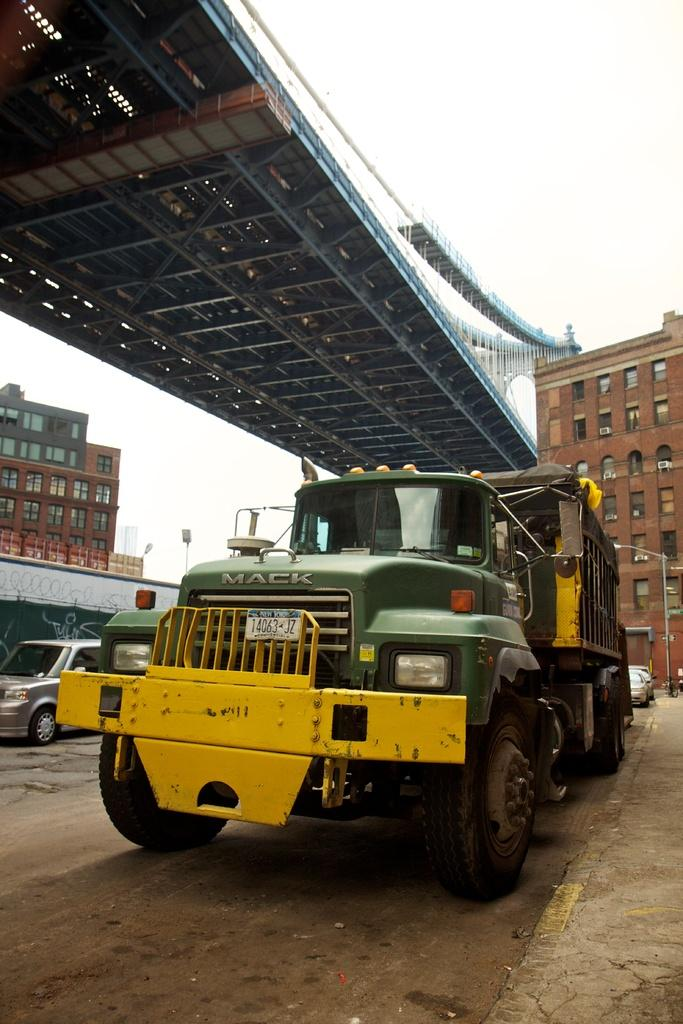<image>
Summarize the visual content of the image. Green and yellow truck with the plate "14063JZ" in front of a building. 